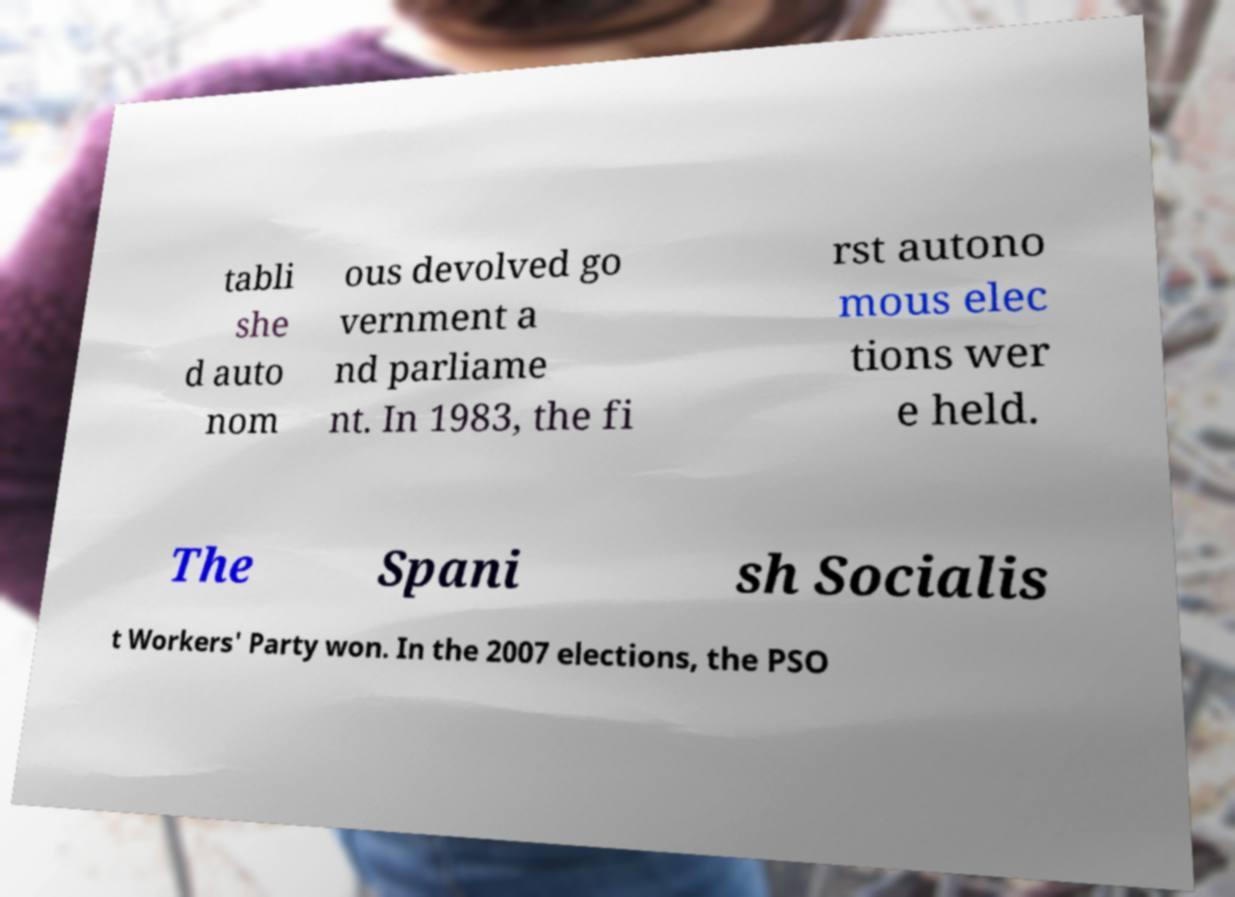Please read and relay the text visible in this image. What does it say? tabli she d auto nom ous devolved go vernment a nd parliame nt. In 1983, the fi rst autono mous elec tions wer e held. The Spani sh Socialis t Workers' Party won. In the 2007 elections, the PSO 